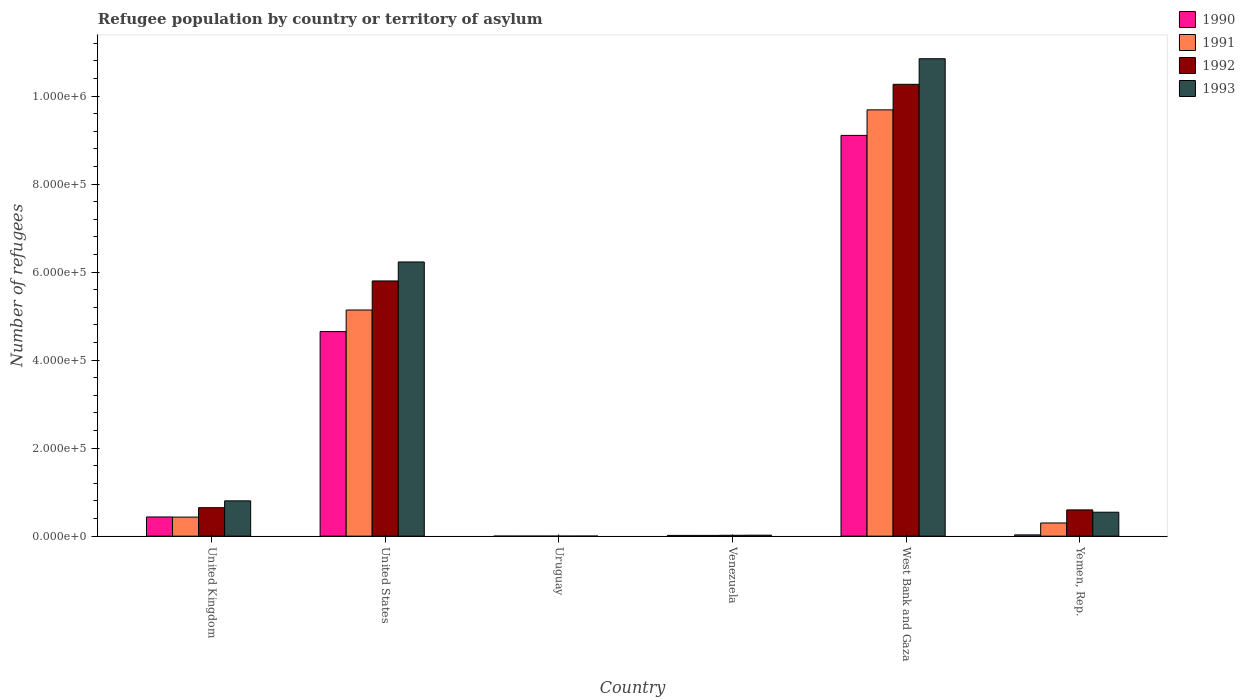Are the number of bars on each tick of the X-axis equal?
Your response must be concise. Yes. How many bars are there on the 3rd tick from the left?
Ensure brevity in your answer.  4. What is the label of the 2nd group of bars from the left?
Your response must be concise. United States. In how many cases, is the number of bars for a given country not equal to the number of legend labels?
Keep it short and to the point. 0. What is the number of refugees in 1992 in Yemen, Rep.?
Your response must be concise. 5.97e+04. Across all countries, what is the maximum number of refugees in 1992?
Provide a short and direct response. 1.03e+06. Across all countries, what is the minimum number of refugees in 1992?
Offer a terse response. 90. In which country was the number of refugees in 1990 maximum?
Keep it short and to the point. West Bank and Gaza. In which country was the number of refugees in 1991 minimum?
Keep it short and to the point. Uruguay. What is the total number of refugees in 1990 in the graph?
Make the answer very short. 1.42e+06. What is the difference between the number of refugees in 1993 in United States and that in Yemen, Rep.?
Keep it short and to the point. 5.69e+05. What is the difference between the number of refugees in 1991 in United Kingdom and the number of refugees in 1993 in West Bank and Gaza?
Offer a very short reply. -1.04e+06. What is the average number of refugees in 1992 per country?
Provide a succinct answer. 2.89e+05. What is the difference between the number of refugees of/in 1991 and number of refugees of/in 1993 in United States?
Give a very brief answer. -1.09e+05. What is the ratio of the number of refugees in 1993 in United Kingdom to that in Uruguay?
Make the answer very short. 581.38. Is the difference between the number of refugees in 1991 in Uruguay and Yemen, Rep. greater than the difference between the number of refugees in 1993 in Uruguay and Yemen, Rep.?
Keep it short and to the point. Yes. What is the difference between the highest and the second highest number of refugees in 1992?
Offer a very short reply. -4.47e+05. What is the difference between the highest and the lowest number of refugees in 1990?
Your response must be concise. 9.11e+05. In how many countries, is the number of refugees in 1992 greater than the average number of refugees in 1992 taken over all countries?
Your response must be concise. 2. Is the sum of the number of refugees in 1993 in United States and Uruguay greater than the maximum number of refugees in 1991 across all countries?
Ensure brevity in your answer.  No. Is it the case that in every country, the sum of the number of refugees in 1991 and number of refugees in 1993 is greater than the sum of number of refugees in 1992 and number of refugees in 1990?
Your answer should be very brief. No. What does the 3rd bar from the left in United Kingdom represents?
Keep it short and to the point. 1992. How many bars are there?
Ensure brevity in your answer.  24. Are all the bars in the graph horizontal?
Give a very brief answer. No. Are the values on the major ticks of Y-axis written in scientific E-notation?
Provide a short and direct response. Yes. How are the legend labels stacked?
Offer a very short reply. Vertical. What is the title of the graph?
Ensure brevity in your answer.  Refugee population by country or territory of asylum. Does "1970" appear as one of the legend labels in the graph?
Your response must be concise. No. What is the label or title of the Y-axis?
Give a very brief answer. Number of refugees. What is the Number of refugees in 1990 in United Kingdom?
Offer a terse response. 4.36e+04. What is the Number of refugees of 1991 in United Kingdom?
Provide a short and direct response. 4.34e+04. What is the Number of refugees in 1992 in United Kingdom?
Offer a very short reply. 6.47e+04. What is the Number of refugees of 1993 in United Kingdom?
Your answer should be compact. 8.02e+04. What is the Number of refugees of 1990 in United States?
Your answer should be very brief. 4.65e+05. What is the Number of refugees of 1991 in United States?
Keep it short and to the point. 5.14e+05. What is the Number of refugees in 1992 in United States?
Your answer should be compact. 5.80e+05. What is the Number of refugees of 1993 in United States?
Offer a terse response. 6.23e+05. What is the Number of refugees in 1992 in Uruguay?
Your answer should be compact. 90. What is the Number of refugees in 1993 in Uruguay?
Your answer should be very brief. 138. What is the Number of refugees of 1990 in Venezuela?
Ensure brevity in your answer.  1750. What is the Number of refugees in 1991 in Venezuela?
Your answer should be very brief. 1720. What is the Number of refugees in 1992 in Venezuela?
Give a very brief answer. 1990. What is the Number of refugees of 1993 in Venezuela?
Provide a short and direct response. 2221. What is the Number of refugees in 1990 in West Bank and Gaza?
Offer a terse response. 9.11e+05. What is the Number of refugees of 1991 in West Bank and Gaza?
Your response must be concise. 9.69e+05. What is the Number of refugees in 1992 in West Bank and Gaza?
Your answer should be compact. 1.03e+06. What is the Number of refugees of 1993 in West Bank and Gaza?
Make the answer very short. 1.08e+06. What is the Number of refugees of 1990 in Yemen, Rep.?
Your response must be concise. 2938. What is the Number of refugees in 1991 in Yemen, Rep.?
Give a very brief answer. 3.00e+04. What is the Number of refugees of 1992 in Yemen, Rep.?
Offer a terse response. 5.97e+04. What is the Number of refugees of 1993 in Yemen, Rep.?
Ensure brevity in your answer.  5.44e+04. Across all countries, what is the maximum Number of refugees in 1990?
Give a very brief answer. 9.11e+05. Across all countries, what is the maximum Number of refugees of 1991?
Provide a succinct answer. 9.69e+05. Across all countries, what is the maximum Number of refugees in 1992?
Keep it short and to the point. 1.03e+06. Across all countries, what is the maximum Number of refugees in 1993?
Your answer should be compact. 1.08e+06. Across all countries, what is the minimum Number of refugees of 1990?
Keep it short and to the point. 87. Across all countries, what is the minimum Number of refugees of 1993?
Give a very brief answer. 138. What is the total Number of refugees in 1990 in the graph?
Make the answer very short. 1.42e+06. What is the total Number of refugees of 1991 in the graph?
Offer a very short reply. 1.56e+06. What is the total Number of refugees in 1992 in the graph?
Your answer should be compact. 1.73e+06. What is the total Number of refugees in 1993 in the graph?
Provide a short and direct response. 1.84e+06. What is the difference between the Number of refugees of 1990 in United Kingdom and that in United States?
Provide a short and direct response. -4.21e+05. What is the difference between the Number of refugees in 1991 in United Kingdom and that in United States?
Provide a succinct answer. -4.71e+05. What is the difference between the Number of refugees in 1992 in United Kingdom and that in United States?
Make the answer very short. -5.15e+05. What is the difference between the Number of refugees of 1993 in United Kingdom and that in United States?
Your answer should be compact. -5.43e+05. What is the difference between the Number of refugees of 1990 in United Kingdom and that in Uruguay?
Ensure brevity in your answer.  4.35e+04. What is the difference between the Number of refugees in 1991 in United Kingdom and that in Uruguay?
Offer a terse response. 4.33e+04. What is the difference between the Number of refugees of 1992 in United Kingdom and that in Uruguay?
Your answer should be compact. 6.46e+04. What is the difference between the Number of refugees of 1993 in United Kingdom and that in Uruguay?
Give a very brief answer. 8.01e+04. What is the difference between the Number of refugees in 1990 in United Kingdom and that in Venezuela?
Provide a short and direct response. 4.19e+04. What is the difference between the Number of refugees in 1991 in United Kingdom and that in Venezuela?
Your response must be concise. 4.17e+04. What is the difference between the Number of refugees in 1992 in United Kingdom and that in Venezuela?
Provide a succinct answer. 6.27e+04. What is the difference between the Number of refugees in 1993 in United Kingdom and that in Venezuela?
Keep it short and to the point. 7.80e+04. What is the difference between the Number of refugees in 1990 in United Kingdom and that in West Bank and Gaza?
Make the answer very short. -8.67e+05. What is the difference between the Number of refugees in 1991 in United Kingdom and that in West Bank and Gaza?
Offer a terse response. -9.25e+05. What is the difference between the Number of refugees of 1992 in United Kingdom and that in West Bank and Gaza?
Offer a terse response. -9.62e+05. What is the difference between the Number of refugees in 1993 in United Kingdom and that in West Bank and Gaza?
Give a very brief answer. -1.00e+06. What is the difference between the Number of refugees in 1990 in United Kingdom and that in Yemen, Rep.?
Your response must be concise. 4.07e+04. What is the difference between the Number of refugees of 1991 in United Kingdom and that in Yemen, Rep.?
Your answer should be compact. 1.34e+04. What is the difference between the Number of refugees of 1992 in United Kingdom and that in Yemen, Rep.?
Make the answer very short. 5046. What is the difference between the Number of refugees in 1993 in United Kingdom and that in Yemen, Rep.?
Offer a terse response. 2.58e+04. What is the difference between the Number of refugees of 1990 in United States and that in Uruguay?
Your answer should be very brief. 4.65e+05. What is the difference between the Number of refugees of 1991 in United States and that in Uruguay?
Offer a terse response. 5.14e+05. What is the difference between the Number of refugees in 1992 in United States and that in Uruguay?
Your answer should be compact. 5.80e+05. What is the difference between the Number of refugees of 1993 in United States and that in Uruguay?
Give a very brief answer. 6.23e+05. What is the difference between the Number of refugees in 1990 in United States and that in Venezuela?
Your answer should be very brief. 4.63e+05. What is the difference between the Number of refugees of 1991 in United States and that in Venezuela?
Keep it short and to the point. 5.12e+05. What is the difference between the Number of refugees in 1992 in United States and that in Venezuela?
Offer a terse response. 5.78e+05. What is the difference between the Number of refugees in 1993 in United States and that in Venezuela?
Provide a short and direct response. 6.21e+05. What is the difference between the Number of refugees of 1990 in United States and that in West Bank and Gaza?
Provide a short and direct response. -4.46e+05. What is the difference between the Number of refugees of 1991 in United States and that in West Bank and Gaza?
Provide a short and direct response. -4.55e+05. What is the difference between the Number of refugees in 1992 in United States and that in West Bank and Gaza?
Offer a terse response. -4.47e+05. What is the difference between the Number of refugees in 1993 in United States and that in West Bank and Gaza?
Provide a succinct answer. -4.62e+05. What is the difference between the Number of refugees in 1990 in United States and that in Yemen, Rep.?
Offer a very short reply. 4.62e+05. What is the difference between the Number of refugees of 1991 in United States and that in Yemen, Rep.?
Your answer should be compact. 4.84e+05. What is the difference between the Number of refugees of 1992 in United States and that in Yemen, Rep.?
Keep it short and to the point. 5.20e+05. What is the difference between the Number of refugees of 1993 in United States and that in Yemen, Rep.?
Your response must be concise. 5.69e+05. What is the difference between the Number of refugees of 1990 in Uruguay and that in Venezuela?
Your answer should be compact. -1663. What is the difference between the Number of refugees in 1991 in Uruguay and that in Venezuela?
Offer a terse response. -1639. What is the difference between the Number of refugees of 1992 in Uruguay and that in Venezuela?
Provide a short and direct response. -1900. What is the difference between the Number of refugees of 1993 in Uruguay and that in Venezuela?
Give a very brief answer. -2083. What is the difference between the Number of refugees in 1990 in Uruguay and that in West Bank and Gaza?
Keep it short and to the point. -9.11e+05. What is the difference between the Number of refugees in 1991 in Uruguay and that in West Bank and Gaza?
Provide a short and direct response. -9.69e+05. What is the difference between the Number of refugees of 1992 in Uruguay and that in West Bank and Gaza?
Ensure brevity in your answer.  -1.03e+06. What is the difference between the Number of refugees of 1993 in Uruguay and that in West Bank and Gaza?
Your response must be concise. -1.08e+06. What is the difference between the Number of refugees of 1990 in Uruguay and that in Yemen, Rep.?
Your answer should be very brief. -2851. What is the difference between the Number of refugees in 1991 in Uruguay and that in Yemen, Rep.?
Offer a terse response. -2.99e+04. What is the difference between the Number of refugees of 1992 in Uruguay and that in Yemen, Rep.?
Ensure brevity in your answer.  -5.96e+04. What is the difference between the Number of refugees of 1993 in Uruguay and that in Yemen, Rep.?
Offer a terse response. -5.43e+04. What is the difference between the Number of refugees in 1990 in Venezuela and that in West Bank and Gaza?
Offer a very short reply. -9.09e+05. What is the difference between the Number of refugees of 1991 in Venezuela and that in West Bank and Gaza?
Your answer should be compact. -9.67e+05. What is the difference between the Number of refugees of 1992 in Venezuela and that in West Bank and Gaza?
Give a very brief answer. -1.02e+06. What is the difference between the Number of refugees in 1993 in Venezuela and that in West Bank and Gaza?
Give a very brief answer. -1.08e+06. What is the difference between the Number of refugees of 1990 in Venezuela and that in Yemen, Rep.?
Your response must be concise. -1188. What is the difference between the Number of refugees in 1991 in Venezuela and that in Yemen, Rep.?
Offer a very short reply. -2.83e+04. What is the difference between the Number of refugees of 1992 in Venezuela and that in Yemen, Rep.?
Your answer should be compact. -5.77e+04. What is the difference between the Number of refugees of 1993 in Venezuela and that in Yemen, Rep.?
Make the answer very short. -5.22e+04. What is the difference between the Number of refugees of 1990 in West Bank and Gaza and that in Yemen, Rep.?
Make the answer very short. 9.08e+05. What is the difference between the Number of refugees of 1991 in West Bank and Gaza and that in Yemen, Rep.?
Give a very brief answer. 9.39e+05. What is the difference between the Number of refugees in 1992 in West Bank and Gaza and that in Yemen, Rep.?
Offer a very short reply. 9.67e+05. What is the difference between the Number of refugees of 1993 in West Bank and Gaza and that in Yemen, Rep.?
Keep it short and to the point. 1.03e+06. What is the difference between the Number of refugees of 1990 in United Kingdom and the Number of refugees of 1991 in United States?
Offer a terse response. -4.70e+05. What is the difference between the Number of refugees of 1990 in United Kingdom and the Number of refugees of 1992 in United States?
Make the answer very short. -5.36e+05. What is the difference between the Number of refugees in 1990 in United Kingdom and the Number of refugees in 1993 in United States?
Provide a short and direct response. -5.79e+05. What is the difference between the Number of refugees in 1991 in United Kingdom and the Number of refugees in 1992 in United States?
Ensure brevity in your answer.  -5.37e+05. What is the difference between the Number of refugees of 1991 in United Kingdom and the Number of refugees of 1993 in United States?
Give a very brief answer. -5.80e+05. What is the difference between the Number of refugees in 1992 in United Kingdom and the Number of refugees in 1993 in United States?
Make the answer very short. -5.58e+05. What is the difference between the Number of refugees in 1990 in United Kingdom and the Number of refugees in 1991 in Uruguay?
Offer a terse response. 4.36e+04. What is the difference between the Number of refugees of 1990 in United Kingdom and the Number of refugees of 1992 in Uruguay?
Make the answer very short. 4.35e+04. What is the difference between the Number of refugees in 1990 in United Kingdom and the Number of refugees in 1993 in Uruguay?
Make the answer very short. 4.35e+04. What is the difference between the Number of refugees in 1991 in United Kingdom and the Number of refugees in 1992 in Uruguay?
Give a very brief answer. 4.33e+04. What is the difference between the Number of refugees in 1991 in United Kingdom and the Number of refugees in 1993 in Uruguay?
Provide a succinct answer. 4.32e+04. What is the difference between the Number of refugees in 1992 in United Kingdom and the Number of refugees in 1993 in Uruguay?
Provide a succinct answer. 6.46e+04. What is the difference between the Number of refugees of 1990 in United Kingdom and the Number of refugees of 1991 in Venezuela?
Make the answer very short. 4.19e+04. What is the difference between the Number of refugees in 1990 in United Kingdom and the Number of refugees in 1992 in Venezuela?
Make the answer very short. 4.16e+04. What is the difference between the Number of refugees of 1990 in United Kingdom and the Number of refugees of 1993 in Venezuela?
Offer a very short reply. 4.14e+04. What is the difference between the Number of refugees in 1991 in United Kingdom and the Number of refugees in 1992 in Venezuela?
Offer a very short reply. 4.14e+04. What is the difference between the Number of refugees in 1991 in United Kingdom and the Number of refugees in 1993 in Venezuela?
Offer a very short reply. 4.12e+04. What is the difference between the Number of refugees of 1992 in United Kingdom and the Number of refugees of 1993 in Venezuela?
Give a very brief answer. 6.25e+04. What is the difference between the Number of refugees in 1990 in United Kingdom and the Number of refugees in 1991 in West Bank and Gaza?
Ensure brevity in your answer.  -9.25e+05. What is the difference between the Number of refugees in 1990 in United Kingdom and the Number of refugees in 1992 in West Bank and Gaza?
Provide a short and direct response. -9.83e+05. What is the difference between the Number of refugees in 1990 in United Kingdom and the Number of refugees in 1993 in West Bank and Gaza?
Offer a very short reply. -1.04e+06. What is the difference between the Number of refugees of 1991 in United Kingdom and the Number of refugees of 1992 in West Bank and Gaza?
Provide a succinct answer. -9.83e+05. What is the difference between the Number of refugees in 1991 in United Kingdom and the Number of refugees in 1993 in West Bank and Gaza?
Your answer should be very brief. -1.04e+06. What is the difference between the Number of refugees of 1992 in United Kingdom and the Number of refugees of 1993 in West Bank and Gaza?
Make the answer very short. -1.02e+06. What is the difference between the Number of refugees of 1990 in United Kingdom and the Number of refugees of 1991 in Yemen, Rep.?
Make the answer very short. 1.37e+04. What is the difference between the Number of refugees of 1990 in United Kingdom and the Number of refugees of 1992 in Yemen, Rep.?
Give a very brief answer. -1.60e+04. What is the difference between the Number of refugees in 1990 in United Kingdom and the Number of refugees in 1993 in Yemen, Rep.?
Offer a very short reply. -1.08e+04. What is the difference between the Number of refugees in 1991 in United Kingdom and the Number of refugees in 1992 in Yemen, Rep.?
Offer a very short reply. -1.63e+04. What is the difference between the Number of refugees in 1991 in United Kingdom and the Number of refugees in 1993 in Yemen, Rep.?
Keep it short and to the point. -1.11e+04. What is the difference between the Number of refugees of 1992 in United Kingdom and the Number of refugees of 1993 in Yemen, Rep.?
Your response must be concise. 1.03e+04. What is the difference between the Number of refugees in 1990 in United States and the Number of refugees in 1991 in Uruguay?
Keep it short and to the point. 4.65e+05. What is the difference between the Number of refugees of 1990 in United States and the Number of refugees of 1992 in Uruguay?
Provide a short and direct response. 4.65e+05. What is the difference between the Number of refugees of 1990 in United States and the Number of refugees of 1993 in Uruguay?
Keep it short and to the point. 4.65e+05. What is the difference between the Number of refugees in 1991 in United States and the Number of refugees in 1992 in Uruguay?
Offer a terse response. 5.14e+05. What is the difference between the Number of refugees of 1991 in United States and the Number of refugees of 1993 in Uruguay?
Provide a succinct answer. 5.14e+05. What is the difference between the Number of refugees in 1992 in United States and the Number of refugees in 1993 in Uruguay?
Keep it short and to the point. 5.80e+05. What is the difference between the Number of refugees in 1990 in United States and the Number of refugees in 1991 in Venezuela?
Offer a very short reply. 4.63e+05. What is the difference between the Number of refugees of 1990 in United States and the Number of refugees of 1992 in Venezuela?
Ensure brevity in your answer.  4.63e+05. What is the difference between the Number of refugees of 1990 in United States and the Number of refugees of 1993 in Venezuela?
Offer a terse response. 4.63e+05. What is the difference between the Number of refugees of 1991 in United States and the Number of refugees of 1992 in Venezuela?
Offer a very short reply. 5.12e+05. What is the difference between the Number of refugees of 1991 in United States and the Number of refugees of 1993 in Venezuela?
Give a very brief answer. 5.12e+05. What is the difference between the Number of refugees of 1992 in United States and the Number of refugees of 1993 in Venezuela?
Provide a short and direct response. 5.78e+05. What is the difference between the Number of refugees of 1990 in United States and the Number of refugees of 1991 in West Bank and Gaza?
Give a very brief answer. -5.04e+05. What is the difference between the Number of refugees in 1990 in United States and the Number of refugees in 1992 in West Bank and Gaza?
Keep it short and to the point. -5.62e+05. What is the difference between the Number of refugees in 1990 in United States and the Number of refugees in 1993 in West Bank and Gaza?
Provide a succinct answer. -6.20e+05. What is the difference between the Number of refugees in 1991 in United States and the Number of refugees in 1992 in West Bank and Gaza?
Give a very brief answer. -5.13e+05. What is the difference between the Number of refugees of 1991 in United States and the Number of refugees of 1993 in West Bank and Gaza?
Ensure brevity in your answer.  -5.71e+05. What is the difference between the Number of refugees of 1992 in United States and the Number of refugees of 1993 in West Bank and Gaza?
Provide a succinct answer. -5.05e+05. What is the difference between the Number of refugees of 1990 in United States and the Number of refugees of 1991 in Yemen, Rep.?
Offer a terse response. 4.35e+05. What is the difference between the Number of refugees in 1990 in United States and the Number of refugees in 1992 in Yemen, Rep.?
Your response must be concise. 4.05e+05. What is the difference between the Number of refugees of 1990 in United States and the Number of refugees of 1993 in Yemen, Rep.?
Ensure brevity in your answer.  4.10e+05. What is the difference between the Number of refugees of 1991 in United States and the Number of refugees of 1992 in Yemen, Rep.?
Provide a short and direct response. 4.54e+05. What is the difference between the Number of refugees in 1991 in United States and the Number of refugees in 1993 in Yemen, Rep.?
Offer a terse response. 4.59e+05. What is the difference between the Number of refugees of 1992 in United States and the Number of refugees of 1993 in Yemen, Rep.?
Offer a terse response. 5.26e+05. What is the difference between the Number of refugees in 1990 in Uruguay and the Number of refugees in 1991 in Venezuela?
Your answer should be compact. -1633. What is the difference between the Number of refugees of 1990 in Uruguay and the Number of refugees of 1992 in Venezuela?
Your answer should be compact. -1903. What is the difference between the Number of refugees in 1990 in Uruguay and the Number of refugees in 1993 in Venezuela?
Your response must be concise. -2134. What is the difference between the Number of refugees in 1991 in Uruguay and the Number of refugees in 1992 in Venezuela?
Offer a very short reply. -1909. What is the difference between the Number of refugees of 1991 in Uruguay and the Number of refugees of 1993 in Venezuela?
Ensure brevity in your answer.  -2140. What is the difference between the Number of refugees of 1992 in Uruguay and the Number of refugees of 1993 in Venezuela?
Provide a short and direct response. -2131. What is the difference between the Number of refugees in 1990 in Uruguay and the Number of refugees in 1991 in West Bank and Gaza?
Make the answer very short. -9.69e+05. What is the difference between the Number of refugees in 1990 in Uruguay and the Number of refugees in 1992 in West Bank and Gaza?
Provide a succinct answer. -1.03e+06. What is the difference between the Number of refugees of 1990 in Uruguay and the Number of refugees of 1993 in West Bank and Gaza?
Provide a succinct answer. -1.08e+06. What is the difference between the Number of refugees of 1991 in Uruguay and the Number of refugees of 1992 in West Bank and Gaza?
Give a very brief answer. -1.03e+06. What is the difference between the Number of refugees in 1991 in Uruguay and the Number of refugees in 1993 in West Bank and Gaza?
Provide a succinct answer. -1.08e+06. What is the difference between the Number of refugees of 1992 in Uruguay and the Number of refugees of 1993 in West Bank and Gaza?
Keep it short and to the point. -1.08e+06. What is the difference between the Number of refugees in 1990 in Uruguay and the Number of refugees in 1991 in Yemen, Rep.?
Provide a succinct answer. -2.99e+04. What is the difference between the Number of refugees in 1990 in Uruguay and the Number of refugees in 1992 in Yemen, Rep.?
Make the answer very short. -5.96e+04. What is the difference between the Number of refugees of 1990 in Uruguay and the Number of refugees of 1993 in Yemen, Rep.?
Offer a terse response. -5.44e+04. What is the difference between the Number of refugees in 1991 in Uruguay and the Number of refugees in 1992 in Yemen, Rep.?
Offer a terse response. -5.96e+04. What is the difference between the Number of refugees in 1991 in Uruguay and the Number of refugees in 1993 in Yemen, Rep.?
Keep it short and to the point. -5.44e+04. What is the difference between the Number of refugees of 1992 in Uruguay and the Number of refugees of 1993 in Yemen, Rep.?
Your answer should be very brief. -5.44e+04. What is the difference between the Number of refugees in 1990 in Venezuela and the Number of refugees in 1991 in West Bank and Gaza?
Offer a very short reply. -9.67e+05. What is the difference between the Number of refugees of 1990 in Venezuela and the Number of refugees of 1992 in West Bank and Gaza?
Offer a terse response. -1.03e+06. What is the difference between the Number of refugees in 1990 in Venezuela and the Number of refugees in 1993 in West Bank and Gaza?
Make the answer very short. -1.08e+06. What is the difference between the Number of refugees in 1991 in Venezuela and the Number of refugees in 1992 in West Bank and Gaza?
Your answer should be compact. -1.03e+06. What is the difference between the Number of refugees in 1991 in Venezuela and the Number of refugees in 1993 in West Bank and Gaza?
Give a very brief answer. -1.08e+06. What is the difference between the Number of refugees of 1992 in Venezuela and the Number of refugees of 1993 in West Bank and Gaza?
Make the answer very short. -1.08e+06. What is the difference between the Number of refugees of 1990 in Venezuela and the Number of refugees of 1991 in Yemen, Rep.?
Your answer should be compact. -2.82e+04. What is the difference between the Number of refugees in 1990 in Venezuela and the Number of refugees in 1992 in Yemen, Rep.?
Keep it short and to the point. -5.79e+04. What is the difference between the Number of refugees of 1990 in Venezuela and the Number of refugees of 1993 in Yemen, Rep.?
Your answer should be very brief. -5.27e+04. What is the difference between the Number of refugees of 1991 in Venezuela and the Number of refugees of 1992 in Yemen, Rep.?
Keep it short and to the point. -5.80e+04. What is the difference between the Number of refugees in 1991 in Venezuela and the Number of refugees in 1993 in Yemen, Rep.?
Ensure brevity in your answer.  -5.27e+04. What is the difference between the Number of refugees in 1992 in Venezuela and the Number of refugees in 1993 in Yemen, Rep.?
Offer a very short reply. -5.25e+04. What is the difference between the Number of refugees in 1990 in West Bank and Gaza and the Number of refugees in 1991 in Yemen, Rep.?
Give a very brief answer. 8.81e+05. What is the difference between the Number of refugees in 1990 in West Bank and Gaza and the Number of refugees in 1992 in Yemen, Rep.?
Ensure brevity in your answer.  8.51e+05. What is the difference between the Number of refugees of 1990 in West Bank and Gaza and the Number of refugees of 1993 in Yemen, Rep.?
Ensure brevity in your answer.  8.56e+05. What is the difference between the Number of refugees in 1991 in West Bank and Gaza and the Number of refugees in 1992 in Yemen, Rep.?
Offer a very short reply. 9.09e+05. What is the difference between the Number of refugees in 1991 in West Bank and Gaza and the Number of refugees in 1993 in Yemen, Rep.?
Offer a very short reply. 9.14e+05. What is the difference between the Number of refugees of 1992 in West Bank and Gaza and the Number of refugees of 1993 in Yemen, Rep.?
Make the answer very short. 9.72e+05. What is the average Number of refugees of 1990 per country?
Ensure brevity in your answer.  2.37e+05. What is the average Number of refugees of 1991 per country?
Give a very brief answer. 2.60e+05. What is the average Number of refugees of 1992 per country?
Your answer should be very brief. 2.89e+05. What is the average Number of refugees in 1993 per country?
Provide a succinct answer. 3.07e+05. What is the difference between the Number of refugees of 1990 and Number of refugees of 1991 in United Kingdom?
Ensure brevity in your answer.  261. What is the difference between the Number of refugees in 1990 and Number of refugees in 1992 in United Kingdom?
Keep it short and to the point. -2.11e+04. What is the difference between the Number of refugees of 1990 and Number of refugees of 1993 in United Kingdom?
Give a very brief answer. -3.66e+04. What is the difference between the Number of refugees in 1991 and Number of refugees in 1992 in United Kingdom?
Your answer should be very brief. -2.14e+04. What is the difference between the Number of refugees in 1991 and Number of refugees in 1993 in United Kingdom?
Your answer should be very brief. -3.69e+04. What is the difference between the Number of refugees of 1992 and Number of refugees of 1993 in United Kingdom?
Ensure brevity in your answer.  -1.55e+04. What is the difference between the Number of refugees of 1990 and Number of refugees of 1991 in United States?
Offer a terse response. -4.90e+04. What is the difference between the Number of refugees of 1990 and Number of refugees of 1992 in United States?
Provide a succinct answer. -1.15e+05. What is the difference between the Number of refugees of 1990 and Number of refugees of 1993 in United States?
Offer a very short reply. -1.58e+05. What is the difference between the Number of refugees of 1991 and Number of refugees of 1992 in United States?
Make the answer very short. -6.61e+04. What is the difference between the Number of refugees in 1991 and Number of refugees in 1993 in United States?
Make the answer very short. -1.09e+05. What is the difference between the Number of refugees in 1992 and Number of refugees in 1993 in United States?
Your response must be concise. -4.31e+04. What is the difference between the Number of refugees in 1990 and Number of refugees in 1991 in Uruguay?
Provide a short and direct response. 6. What is the difference between the Number of refugees in 1990 and Number of refugees in 1993 in Uruguay?
Ensure brevity in your answer.  -51. What is the difference between the Number of refugees in 1991 and Number of refugees in 1992 in Uruguay?
Offer a very short reply. -9. What is the difference between the Number of refugees of 1991 and Number of refugees of 1993 in Uruguay?
Provide a short and direct response. -57. What is the difference between the Number of refugees in 1992 and Number of refugees in 1993 in Uruguay?
Your response must be concise. -48. What is the difference between the Number of refugees in 1990 and Number of refugees in 1992 in Venezuela?
Offer a terse response. -240. What is the difference between the Number of refugees in 1990 and Number of refugees in 1993 in Venezuela?
Your response must be concise. -471. What is the difference between the Number of refugees of 1991 and Number of refugees of 1992 in Venezuela?
Provide a succinct answer. -270. What is the difference between the Number of refugees of 1991 and Number of refugees of 1993 in Venezuela?
Offer a very short reply. -501. What is the difference between the Number of refugees of 1992 and Number of refugees of 1993 in Venezuela?
Offer a terse response. -231. What is the difference between the Number of refugees of 1990 and Number of refugees of 1991 in West Bank and Gaza?
Provide a short and direct response. -5.81e+04. What is the difference between the Number of refugees in 1990 and Number of refugees in 1992 in West Bank and Gaza?
Keep it short and to the point. -1.16e+05. What is the difference between the Number of refugees of 1990 and Number of refugees of 1993 in West Bank and Gaza?
Offer a terse response. -1.74e+05. What is the difference between the Number of refugees of 1991 and Number of refugees of 1992 in West Bank and Gaza?
Ensure brevity in your answer.  -5.81e+04. What is the difference between the Number of refugees in 1991 and Number of refugees in 1993 in West Bank and Gaza?
Make the answer very short. -1.16e+05. What is the difference between the Number of refugees of 1992 and Number of refugees of 1993 in West Bank and Gaza?
Your response must be concise. -5.81e+04. What is the difference between the Number of refugees of 1990 and Number of refugees of 1991 in Yemen, Rep.?
Your response must be concise. -2.70e+04. What is the difference between the Number of refugees in 1990 and Number of refugees in 1992 in Yemen, Rep.?
Your answer should be compact. -5.67e+04. What is the difference between the Number of refugees in 1990 and Number of refugees in 1993 in Yemen, Rep.?
Give a very brief answer. -5.15e+04. What is the difference between the Number of refugees in 1991 and Number of refugees in 1992 in Yemen, Rep.?
Your answer should be compact. -2.97e+04. What is the difference between the Number of refugees in 1991 and Number of refugees in 1993 in Yemen, Rep.?
Ensure brevity in your answer.  -2.45e+04. What is the difference between the Number of refugees in 1992 and Number of refugees in 1993 in Yemen, Rep.?
Keep it short and to the point. 5230. What is the ratio of the Number of refugees in 1990 in United Kingdom to that in United States?
Keep it short and to the point. 0.09. What is the ratio of the Number of refugees in 1991 in United Kingdom to that in United States?
Ensure brevity in your answer.  0.08. What is the ratio of the Number of refugees of 1992 in United Kingdom to that in United States?
Provide a succinct answer. 0.11. What is the ratio of the Number of refugees of 1993 in United Kingdom to that in United States?
Your answer should be compact. 0.13. What is the ratio of the Number of refugees of 1990 in United Kingdom to that in Uruguay?
Offer a terse response. 501.52. What is the ratio of the Number of refugees in 1991 in United Kingdom to that in Uruguay?
Make the answer very short. 535.44. What is the ratio of the Number of refugees of 1992 in United Kingdom to that in Uruguay?
Your response must be concise. 719.18. What is the ratio of the Number of refugees of 1993 in United Kingdom to that in Uruguay?
Your answer should be compact. 581.38. What is the ratio of the Number of refugees of 1990 in United Kingdom to that in Venezuela?
Provide a short and direct response. 24.93. What is the ratio of the Number of refugees in 1991 in United Kingdom to that in Venezuela?
Make the answer very short. 25.22. What is the ratio of the Number of refugees of 1992 in United Kingdom to that in Venezuela?
Your answer should be very brief. 32.53. What is the ratio of the Number of refugees in 1993 in United Kingdom to that in Venezuela?
Your answer should be very brief. 36.12. What is the ratio of the Number of refugees in 1990 in United Kingdom to that in West Bank and Gaza?
Offer a terse response. 0.05. What is the ratio of the Number of refugees in 1991 in United Kingdom to that in West Bank and Gaza?
Keep it short and to the point. 0.04. What is the ratio of the Number of refugees of 1992 in United Kingdom to that in West Bank and Gaza?
Your response must be concise. 0.06. What is the ratio of the Number of refugees of 1993 in United Kingdom to that in West Bank and Gaza?
Your response must be concise. 0.07. What is the ratio of the Number of refugees in 1990 in United Kingdom to that in Yemen, Rep.?
Your answer should be very brief. 14.85. What is the ratio of the Number of refugees of 1991 in United Kingdom to that in Yemen, Rep.?
Offer a very short reply. 1.45. What is the ratio of the Number of refugees of 1992 in United Kingdom to that in Yemen, Rep.?
Your response must be concise. 1.08. What is the ratio of the Number of refugees of 1993 in United Kingdom to that in Yemen, Rep.?
Your answer should be compact. 1.47. What is the ratio of the Number of refugees of 1990 in United States to that in Uruguay?
Offer a terse response. 5343.53. What is the ratio of the Number of refugees of 1991 in United States to that in Uruguay?
Ensure brevity in your answer.  6344.22. What is the ratio of the Number of refugees in 1992 in United States to that in Uruguay?
Your answer should be compact. 6443.91. What is the ratio of the Number of refugees of 1993 in United States to that in Uruguay?
Your answer should be compact. 4514.99. What is the ratio of the Number of refugees of 1990 in United States to that in Venezuela?
Offer a terse response. 265.65. What is the ratio of the Number of refugees of 1991 in United States to that in Venezuela?
Provide a short and direct response. 298.77. What is the ratio of the Number of refugees of 1992 in United States to that in Venezuela?
Make the answer very short. 291.43. What is the ratio of the Number of refugees of 1993 in United States to that in Venezuela?
Keep it short and to the point. 280.54. What is the ratio of the Number of refugees in 1990 in United States to that in West Bank and Gaza?
Offer a terse response. 0.51. What is the ratio of the Number of refugees in 1991 in United States to that in West Bank and Gaza?
Ensure brevity in your answer.  0.53. What is the ratio of the Number of refugees in 1992 in United States to that in West Bank and Gaza?
Your answer should be very brief. 0.56. What is the ratio of the Number of refugees of 1993 in United States to that in West Bank and Gaza?
Keep it short and to the point. 0.57. What is the ratio of the Number of refugees of 1990 in United States to that in Yemen, Rep.?
Ensure brevity in your answer.  158.23. What is the ratio of the Number of refugees of 1991 in United States to that in Yemen, Rep.?
Make the answer very short. 17.14. What is the ratio of the Number of refugees in 1992 in United States to that in Yemen, Rep.?
Provide a short and direct response. 9.72. What is the ratio of the Number of refugees of 1993 in United States to that in Yemen, Rep.?
Keep it short and to the point. 11.44. What is the ratio of the Number of refugees of 1990 in Uruguay to that in Venezuela?
Offer a terse response. 0.05. What is the ratio of the Number of refugees of 1991 in Uruguay to that in Venezuela?
Keep it short and to the point. 0.05. What is the ratio of the Number of refugees of 1992 in Uruguay to that in Venezuela?
Your answer should be compact. 0.05. What is the ratio of the Number of refugees of 1993 in Uruguay to that in Venezuela?
Provide a succinct answer. 0.06. What is the ratio of the Number of refugees in 1991 in Uruguay to that in West Bank and Gaza?
Provide a succinct answer. 0. What is the ratio of the Number of refugees in 1992 in Uruguay to that in West Bank and Gaza?
Give a very brief answer. 0. What is the ratio of the Number of refugees in 1990 in Uruguay to that in Yemen, Rep.?
Your answer should be compact. 0.03. What is the ratio of the Number of refugees of 1991 in Uruguay to that in Yemen, Rep.?
Provide a short and direct response. 0. What is the ratio of the Number of refugees in 1992 in Uruguay to that in Yemen, Rep.?
Offer a very short reply. 0. What is the ratio of the Number of refugees of 1993 in Uruguay to that in Yemen, Rep.?
Your response must be concise. 0. What is the ratio of the Number of refugees of 1990 in Venezuela to that in West Bank and Gaza?
Provide a short and direct response. 0. What is the ratio of the Number of refugees in 1991 in Venezuela to that in West Bank and Gaza?
Your response must be concise. 0. What is the ratio of the Number of refugees of 1992 in Venezuela to that in West Bank and Gaza?
Ensure brevity in your answer.  0. What is the ratio of the Number of refugees of 1993 in Venezuela to that in West Bank and Gaza?
Your answer should be very brief. 0. What is the ratio of the Number of refugees in 1990 in Venezuela to that in Yemen, Rep.?
Provide a succinct answer. 0.6. What is the ratio of the Number of refugees of 1991 in Venezuela to that in Yemen, Rep.?
Keep it short and to the point. 0.06. What is the ratio of the Number of refugees in 1993 in Venezuela to that in Yemen, Rep.?
Your answer should be very brief. 0.04. What is the ratio of the Number of refugees of 1990 in West Bank and Gaza to that in Yemen, Rep.?
Provide a succinct answer. 309.95. What is the ratio of the Number of refugees in 1991 in West Bank and Gaza to that in Yemen, Rep.?
Give a very brief answer. 32.31. What is the ratio of the Number of refugees of 1992 in West Bank and Gaza to that in Yemen, Rep.?
Give a very brief answer. 17.2. What is the ratio of the Number of refugees in 1993 in West Bank and Gaza to that in Yemen, Rep.?
Provide a succinct answer. 19.92. What is the difference between the highest and the second highest Number of refugees of 1990?
Ensure brevity in your answer.  4.46e+05. What is the difference between the highest and the second highest Number of refugees of 1991?
Offer a very short reply. 4.55e+05. What is the difference between the highest and the second highest Number of refugees of 1992?
Your answer should be very brief. 4.47e+05. What is the difference between the highest and the second highest Number of refugees of 1993?
Give a very brief answer. 4.62e+05. What is the difference between the highest and the lowest Number of refugees of 1990?
Provide a short and direct response. 9.11e+05. What is the difference between the highest and the lowest Number of refugees in 1991?
Offer a very short reply. 9.69e+05. What is the difference between the highest and the lowest Number of refugees of 1992?
Make the answer very short. 1.03e+06. What is the difference between the highest and the lowest Number of refugees in 1993?
Your answer should be compact. 1.08e+06. 